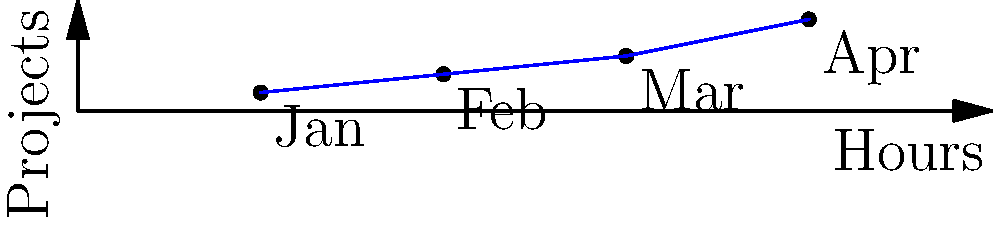The graph shows your community service hours and the number of projects completed over four months. If this trend continues, how many projects would you expect to complete when you reach 50 hours of service? To solve this problem, we need to analyze the trend in the data and use it to make a prediction. Let's follow these steps:

1. Observe the data points:
   - January: 10 hours, 1 project
   - February: 20 hours, 2 projects
   - March: 30 hours, 3 projects
   - April: 40 hours, 5 projects

2. Identify the pattern:
   The number of projects increases as the number of hours increases, but not at a constant rate.

3. Calculate the rate of change between the last two data points:
   Change in hours: 40 - 30 = 10 hours
   Change in projects: 5 - 3 = 2 projects
   Rate of change: 2 projects / 10 hours = 0.2 projects per hour

4. Use this rate to estimate the number of projects at 50 hours:
   Additional hours beyond the last data point: 50 - 40 = 10 hours
   Estimated additional projects: 10 hours × 0.2 projects/hour = 2 projects

5. Add this to the number of projects at 40 hours:
   Total estimated projects at 50 hours: 5 + 2 = 7 projects

Therefore, if the trend continues, you would expect to complete 7 projects when you reach 50 hours of service.
Answer: 7 projects 